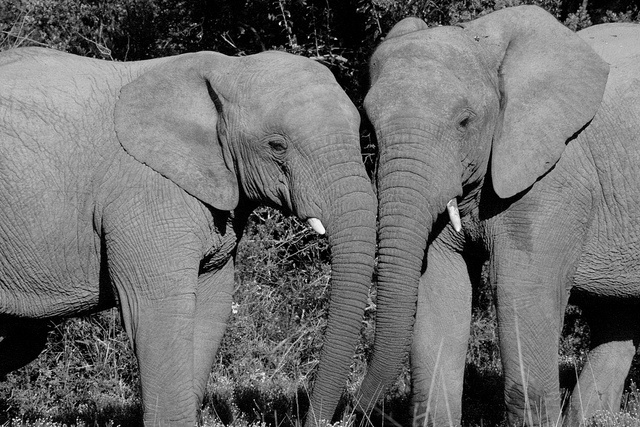Describe the objects in this image and their specific colors. I can see elephant in gray, darkgray, black, and lightgray tones and elephant in gray, darkgray, black, and lightgray tones in this image. 